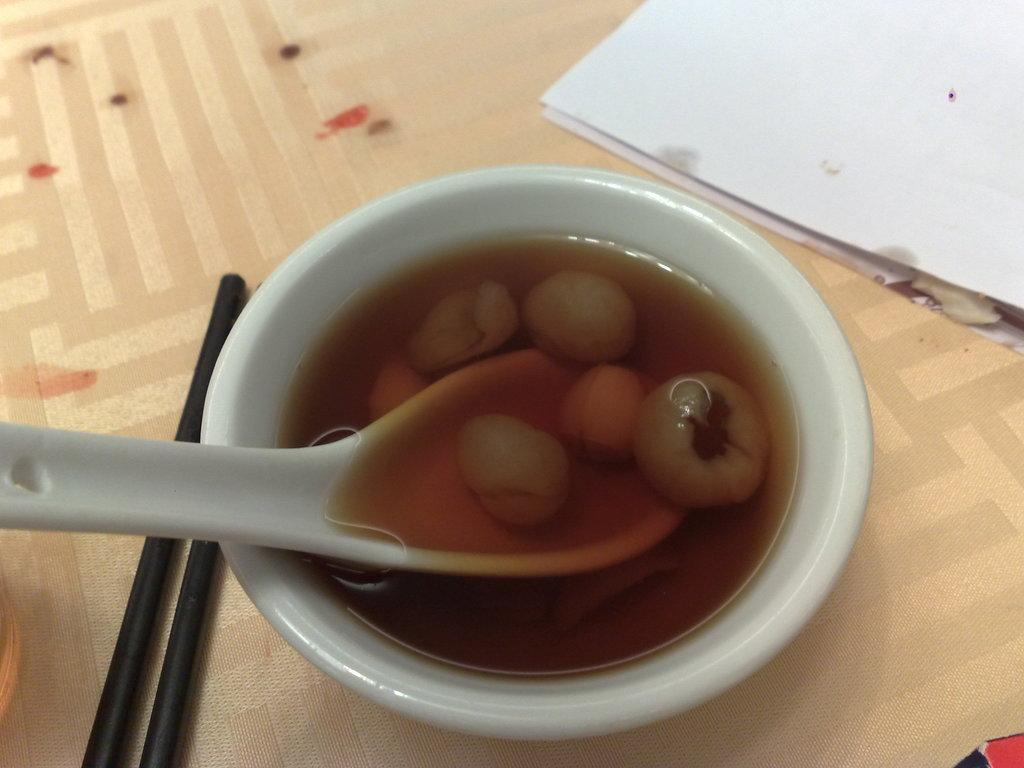What type of objects can be seen in the image? There are food items, a spoon, chopsticks, and papers in the image. Can you describe the spoon's location in the image? The spoon is in a white-colored bowl. What utensil is present in the image besides the spoon? Chopsticks are present in the image. What else can be seen on the surface where the chopsticks and papers are located? The food items are also on the same surface. How many lizards are crawling on the hat in the image? There are no lizards or hats present in the image. What type of lock is used to secure the papers in the image? There is no lock present in the image; the papers are simply placed on a surface. 